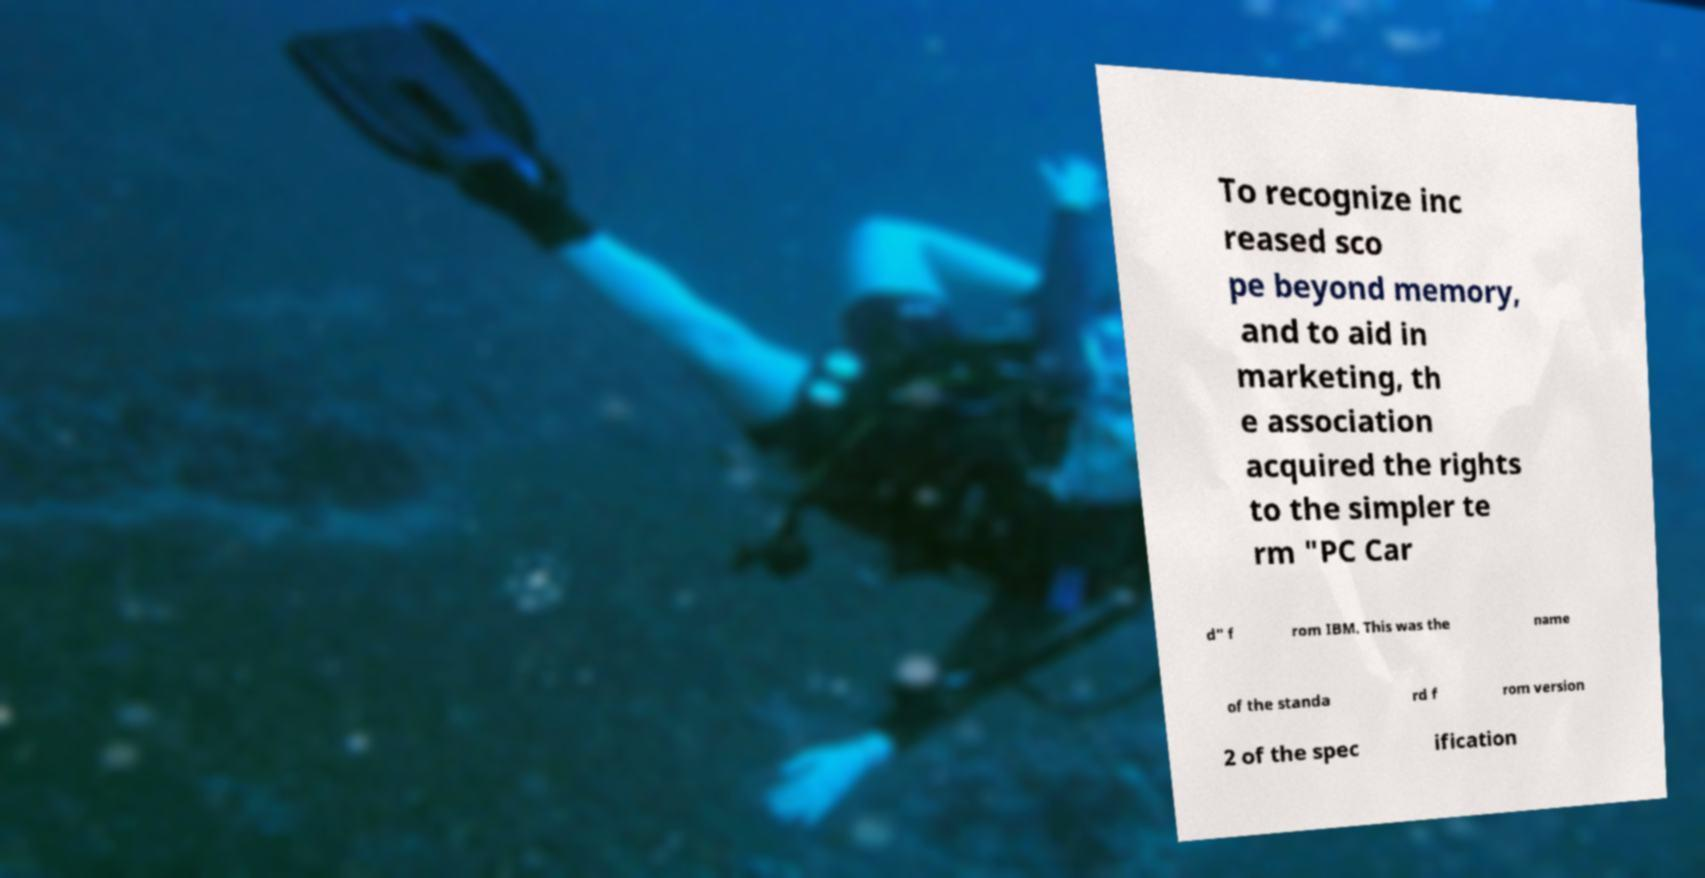Could you extract and type out the text from this image? To recognize inc reased sco pe beyond memory, and to aid in marketing, th e association acquired the rights to the simpler te rm "PC Car d" f rom IBM. This was the name of the standa rd f rom version 2 of the spec ification 